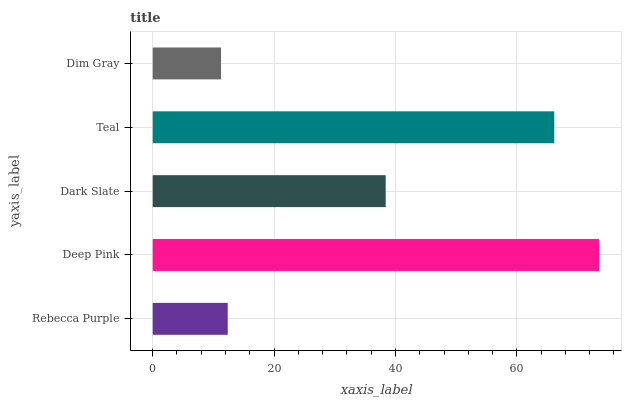Is Dim Gray the minimum?
Answer yes or no. Yes. Is Deep Pink the maximum?
Answer yes or no. Yes. Is Dark Slate the minimum?
Answer yes or no. No. Is Dark Slate the maximum?
Answer yes or no. No. Is Deep Pink greater than Dark Slate?
Answer yes or no. Yes. Is Dark Slate less than Deep Pink?
Answer yes or no. Yes. Is Dark Slate greater than Deep Pink?
Answer yes or no. No. Is Deep Pink less than Dark Slate?
Answer yes or no. No. Is Dark Slate the high median?
Answer yes or no. Yes. Is Dark Slate the low median?
Answer yes or no. Yes. Is Teal the high median?
Answer yes or no. No. Is Rebecca Purple the low median?
Answer yes or no. No. 